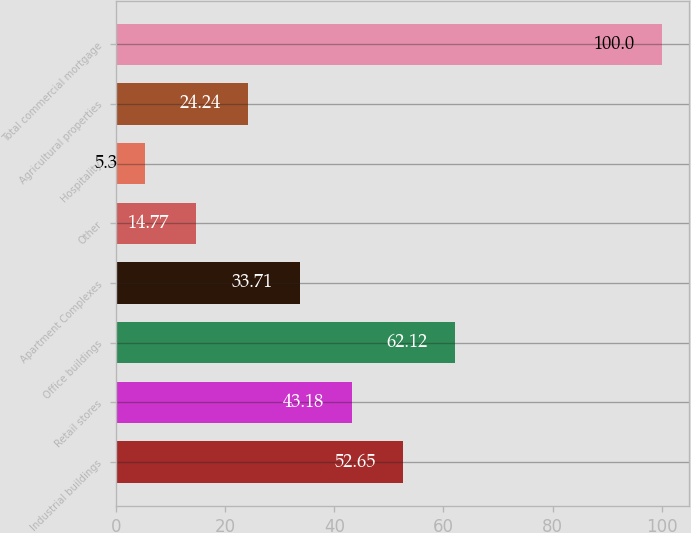Convert chart. <chart><loc_0><loc_0><loc_500><loc_500><bar_chart><fcel>Industrial buildings<fcel>Retail stores<fcel>Office buildings<fcel>Apartment Complexes<fcel>Other<fcel>Hospitality<fcel>Agricultural properties<fcel>Total commercial mortgage<nl><fcel>52.65<fcel>43.18<fcel>62.12<fcel>33.71<fcel>14.77<fcel>5.3<fcel>24.24<fcel>100<nl></chart> 